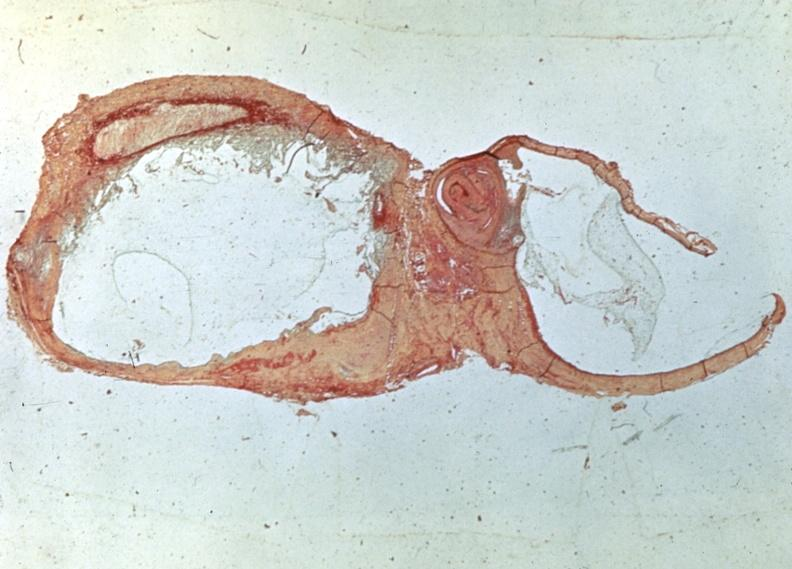s joints present?
Answer the question using a single word or phrase. Yes 